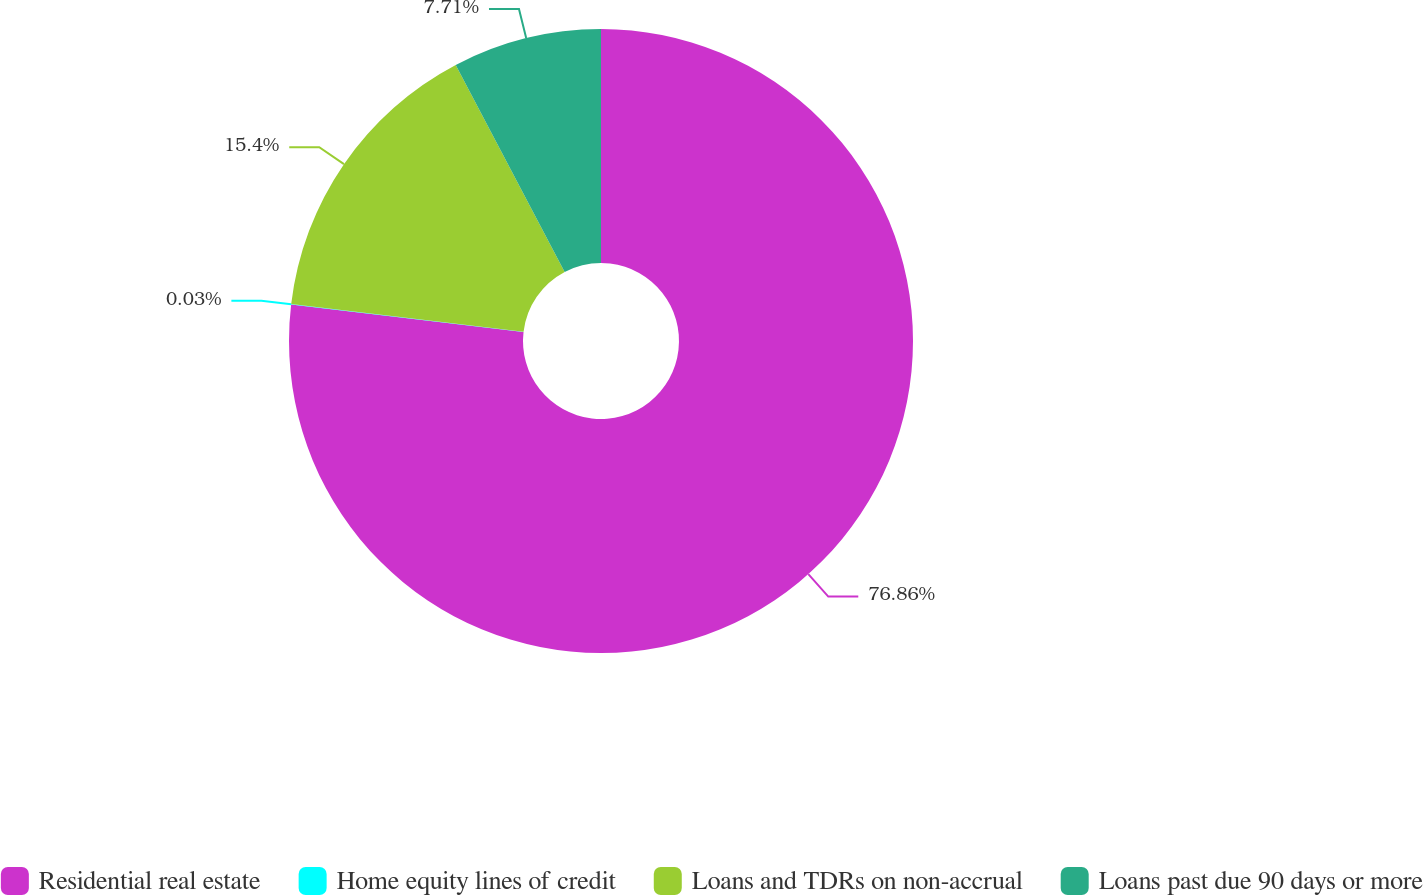<chart> <loc_0><loc_0><loc_500><loc_500><pie_chart><fcel>Residential real estate<fcel>Home equity lines of credit<fcel>Loans and TDRs on non-accrual<fcel>Loans past due 90 days or more<nl><fcel>76.87%<fcel>0.03%<fcel>15.4%<fcel>7.71%<nl></chart> 